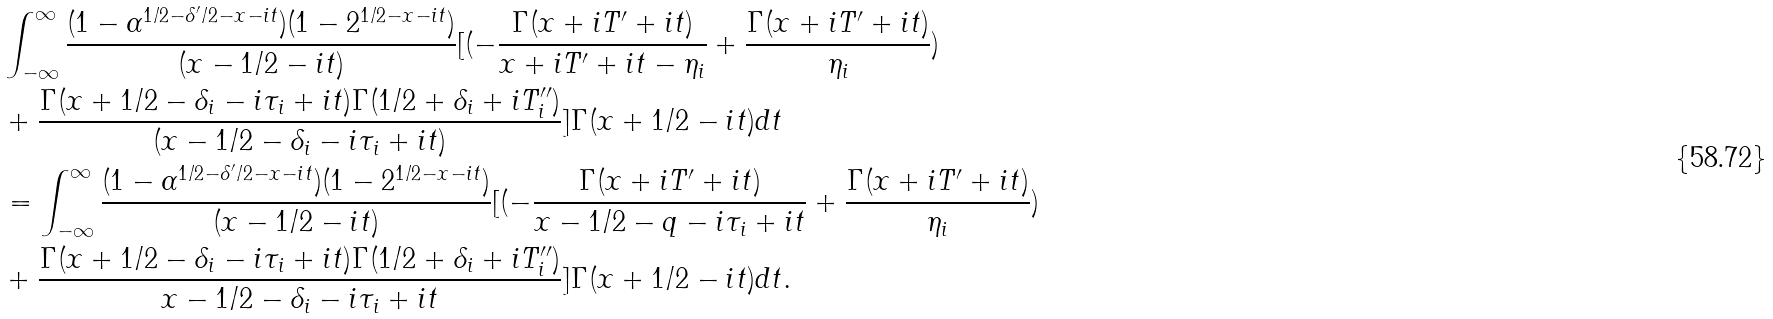<formula> <loc_0><loc_0><loc_500><loc_500>& \int _ { - \infty } ^ { \infty } \frac { ( 1 - \alpha ^ { 1 / 2 - \delta ^ { \prime } / 2 - x - i t } ) ( 1 - 2 ^ { 1 / 2 - x - i t } ) } { ( x - 1 / 2 - i t ) } [ ( - \frac { \Gamma ( x + i T ^ { \prime } + i t ) } { x + i T ^ { \prime } + i t - \eta _ { i } } + \frac { \Gamma ( x + i T ^ { \prime } + i t ) } { \eta _ { i } } ) \\ & + \frac { \Gamma ( x + 1 / 2 - \delta _ { i } - i \tau _ { i } + i t ) \Gamma ( 1 / 2 + \delta _ { i } + i T _ { i } ^ { \prime \prime } ) } { ( x - 1 / 2 - \delta _ { i } - i \tau _ { i } + i t ) } ] \Gamma ( x + 1 / 2 - i t ) d t \\ & = \int _ { - \infty } ^ { \infty } \frac { ( 1 - \alpha ^ { 1 / 2 - \delta ^ { \prime } / 2 - x - i t } ) ( 1 - 2 ^ { 1 / 2 - x - i t } ) } { ( x - 1 / 2 - i t ) } [ ( - \frac { \Gamma ( x + i T ^ { \prime } + i t ) } { x - 1 / 2 - q - i \tau _ { i } + i t } + \frac { \Gamma ( x + i T ^ { \prime } + i t ) } { \eta _ { i } } ) \\ & + \frac { \Gamma ( x + 1 / 2 - \delta _ { i } - i \tau _ { i } + i t ) \Gamma ( 1 / 2 + \delta _ { i } + i T _ { i } ^ { \prime \prime } ) } { x - 1 / 2 - \delta _ { i } - i \tau _ { i } + i t } ] \Gamma ( x + 1 / 2 - i t ) d t .</formula> 